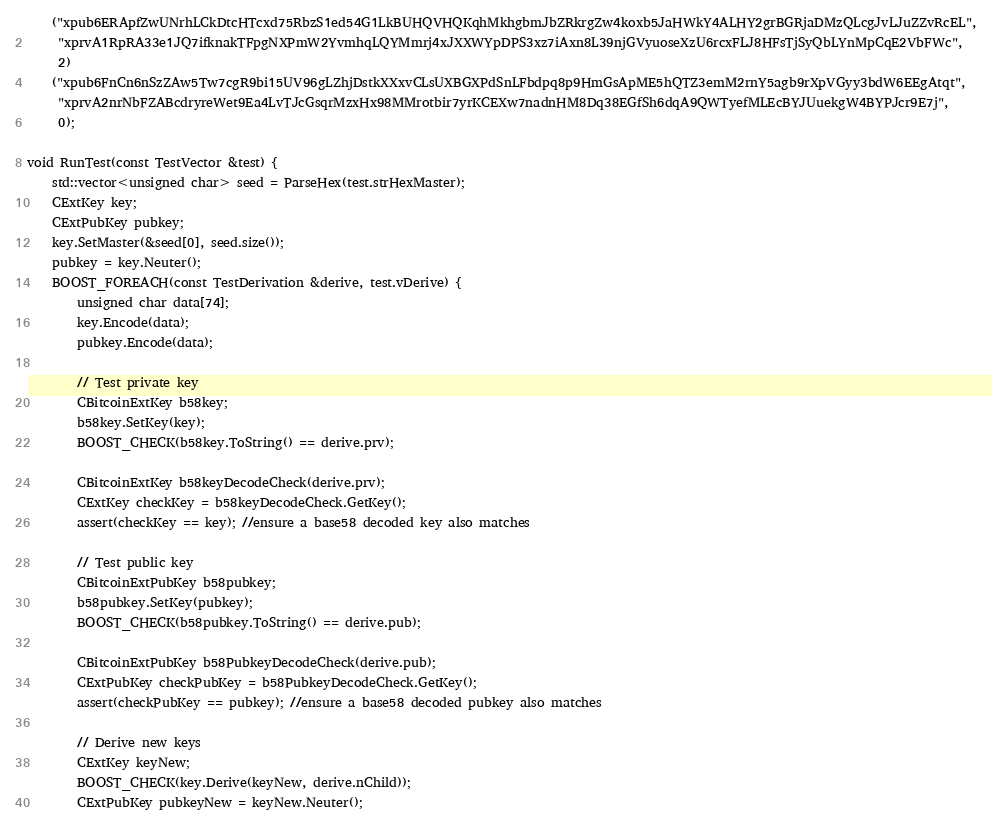Convert code to text. <code><loc_0><loc_0><loc_500><loc_500><_C++_>    ("xpub6ERApfZwUNrhLCkDtcHTcxd75RbzS1ed54G1LkBUHQVHQKqhMkhgbmJbZRkrgZw4koxb5JaHWkY4ALHY2grBGRjaDMzQLcgJvLJuZZvRcEL",
     "xprvA1RpRA33e1JQ7ifknakTFpgNXPmW2YvmhqLQYMmrj4xJXXWYpDPS3xz7iAxn8L39njGVyuoseXzU6rcxFLJ8HFsTjSyQbLYnMpCqE2VbFWc",
     2)
    ("xpub6FnCn6nSzZAw5Tw7cgR9bi15UV96gLZhjDstkXXxvCLsUXBGXPdSnLFbdpq8p9HmGsApME5hQTZ3emM2rnY5agb9rXpVGyy3bdW6EEgAtqt",
     "xprvA2nrNbFZABcdryreWet9Ea4LvTJcGsqrMzxHx98MMrotbir7yrKCEXw7nadnHM8Dq38EGfSh6dqA9QWTyefMLEcBYJUuekgW4BYPJcr9E7j",
     0);

void RunTest(const TestVector &test) {
    std::vector<unsigned char> seed = ParseHex(test.strHexMaster);
    CExtKey key;
    CExtPubKey pubkey;
    key.SetMaster(&seed[0], seed.size());
    pubkey = key.Neuter();
    BOOST_FOREACH(const TestDerivation &derive, test.vDerive) {
        unsigned char data[74];
        key.Encode(data);
        pubkey.Encode(data);

        // Test private key
        CBitcoinExtKey b58key;
        b58key.SetKey(key);
        BOOST_CHECK(b58key.ToString() == derive.prv);

        CBitcoinExtKey b58keyDecodeCheck(derive.prv);
        CExtKey checkKey = b58keyDecodeCheck.GetKey();
        assert(checkKey == key); //ensure a base58 decoded key also matches

        // Test public key
        CBitcoinExtPubKey b58pubkey;
        b58pubkey.SetKey(pubkey);
        BOOST_CHECK(b58pubkey.ToString() == derive.pub);

        CBitcoinExtPubKey b58PubkeyDecodeCheck(derive.pub);
        CExtPubKey checkPubKey = b58PubkeyDecodeCheck.GetKey();
        assert(checkPubKey == pubkey); //ensure a base58 decoded pubkey also matches

        // Derive new keys
        CExtKey keyNew;
        BOOST_CHECK(key.Derive(keyNew, derive.nChild));
        CExtPubKey pubkeyNew = keyNew.Neuter();</code> 